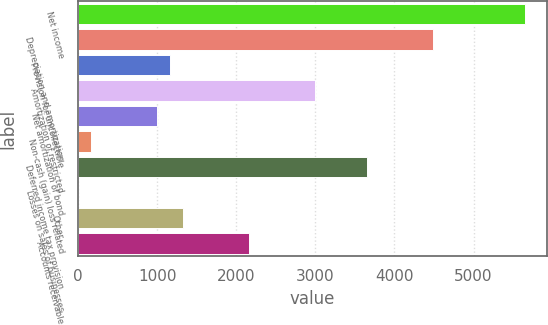<chart> <loc_0><loc_0><loc_500><loc_500><bar_chart><fcel>Net income<fcel>Depreciation and amortization<fcel>Provision for uncollectible<fcel>Amortization of restricted<fcel>Net amortization of bond<fcel>Non-cash (gain) loss related<fcel>Deferred income tax provision<fcel>Losses on sales of businesses<fcel>Other<fcel>Accounts receivable<nl><fcel>5645.56<fcel>4483.28<fcel>1162.48<fcel>2988.92<fcel>996.44<fcel>166.24<fcel>3653.08<fcel>0.2<fcel>1328.52<fcel>2158.72<nl></chart> 